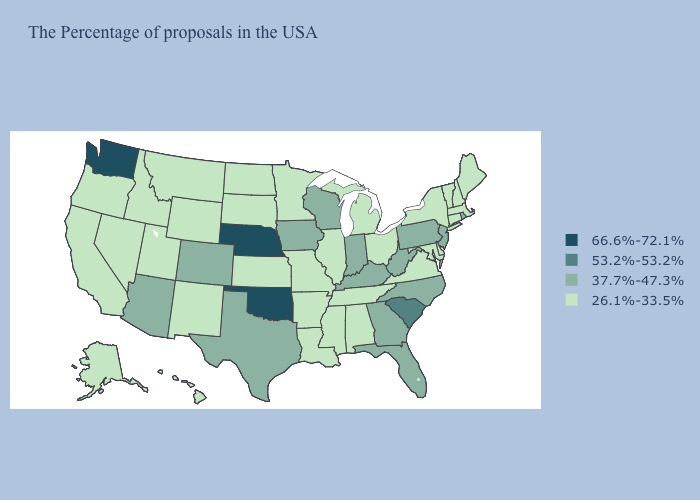What is the value of Alabama?
Concise answer only. 26.1%-33.5%. Does Ohio have the same value as Montana?
Concise answer only. Yes. What is the lowest value in states that border Kentucky?
Write a very short answer. 26.1%-33.5%. What is the highest value in states that border New York?
Answer briefly. 37.7%-47.3%. What is the value of Georgia?
Concise answer only. 37.7%-47.3%. What is the value of Wyoming?
Be succinct. 26.1%-33.5%. Among the states that border Kentucky , does Tennessee have the lowest value?
Concise answer only. Yes. Name the states that have a value in the range 66.6%-72.1%?
Be succinct. Nebraska, Oklahoma, Washington. How many symbols are there in the legend?
Write a very short answer. 4. Does Oregon have the highest value in the USA?
Quick response, please. No. Does the map have missing data?
Keep it brief. No. Does Pennsylvania have the lowest value in the Northeast?
Be succinct. No. Which states have the highest value in the USA?
Short answer required. Nebraska, Oklahoma, Washington. Among the states that border Virginia , does West Virginia have the highest value?
Concise answer only. Yes. Among the states that border Virginia , does Tennessee have the lowest value?
Concise answer only. Yes. 